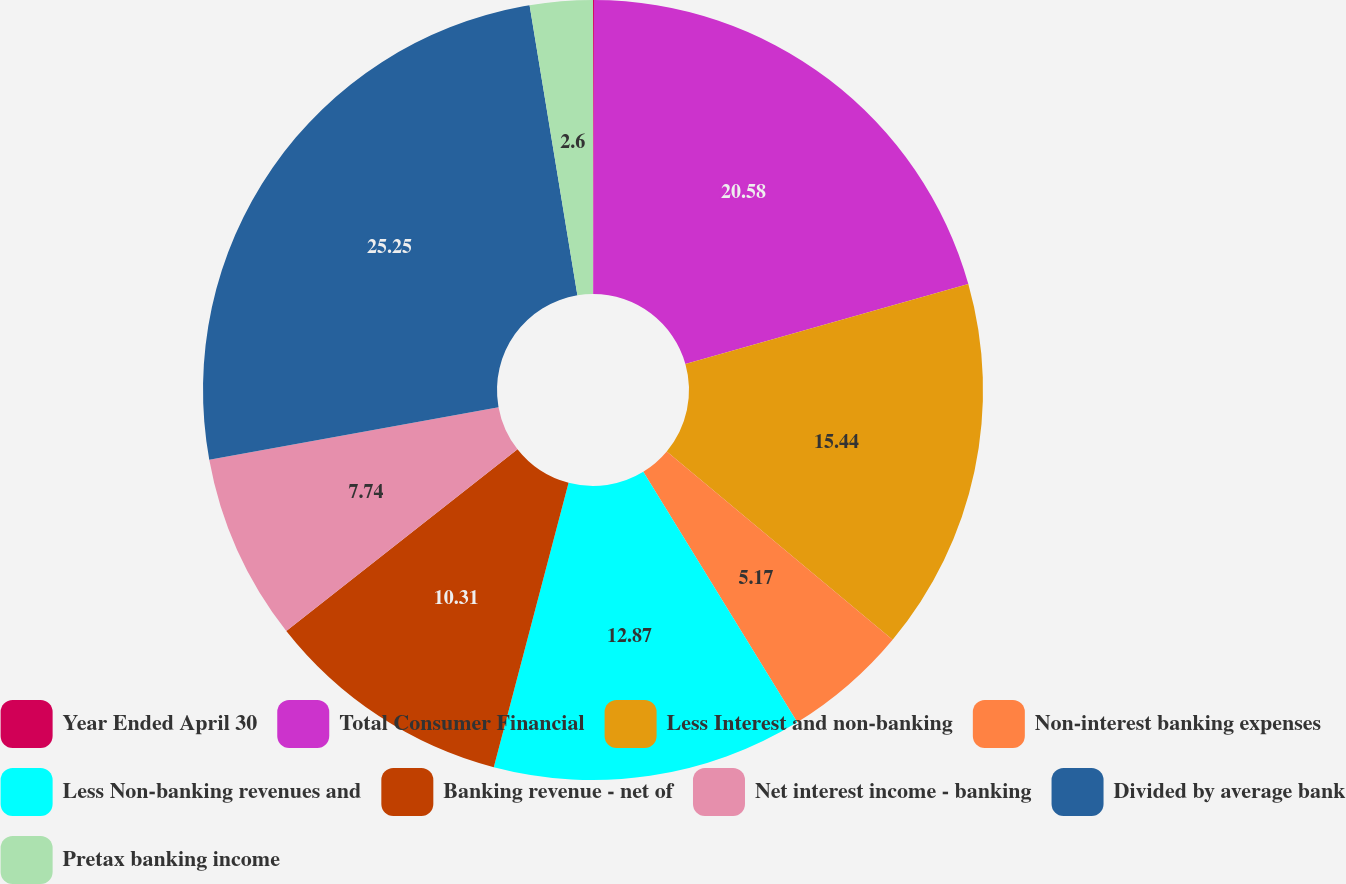Convert chart. <chart><loc_0><loc_0><loc_500><loc_500><pie_chart><fcel>Year Ended April 30<fcel>Total Consumer Financial<fcel>Less Interest and non-banking<fcel>Non-interest banking expenses<fcel>Less Non-banking revenues and<fcel>Banking revenue - net of<fcel>Net interest income - banking<fcel>Divided by average bank<fcel>Pretax banking income<nl><fcel>0.04%<fcel>20.58%<fcel>15.44%<fcel>5.17%<fcel>12.87%<fcel>10.31%<fcel>7.74%<fcel>25.26%<fcel>2.6%<nl></chart> 